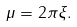Convert formula to latex. <formula><loc_0><loc_0><loc_500><loc_500>\mu = 2 \pi \xi .</formula> 